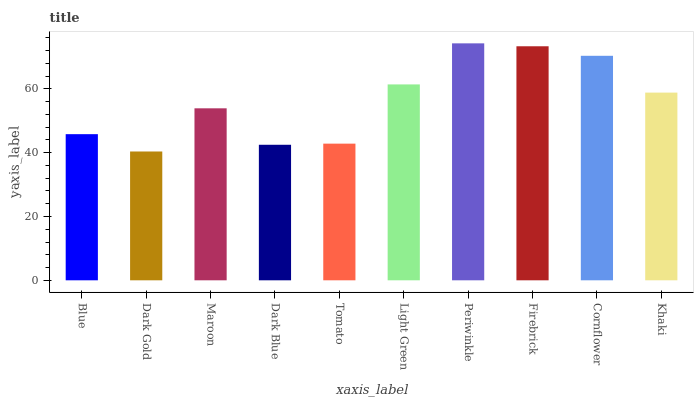Is Dark Gold the minimum?
Answer yes or no. Yes. Is Periwinkle the maximum?
Answer yes or no. Yes. Is Maroon the minimum?
Answer yes or no. No. Is Maroon the maximum?
Answer yes or no. No. Is Maroon greater than Dark Gold?
Answer yes or no. Yes. Is Dark Gold less than Maroon?
Answer yes or no. Yes. Is Dark Gold greater than Maroon?
Answer yes or no. No. Is Maroon less than Dark Gold?
Answer yes or no. No. Is Khaki the high median?
Answer yes or no. Yes. Is Maroon the low median?
Answer yes or no. Yes. Is Periwinkle the high median?
Answer yes or no. No. Is Blue the low median?
Answer yes or no. No. 